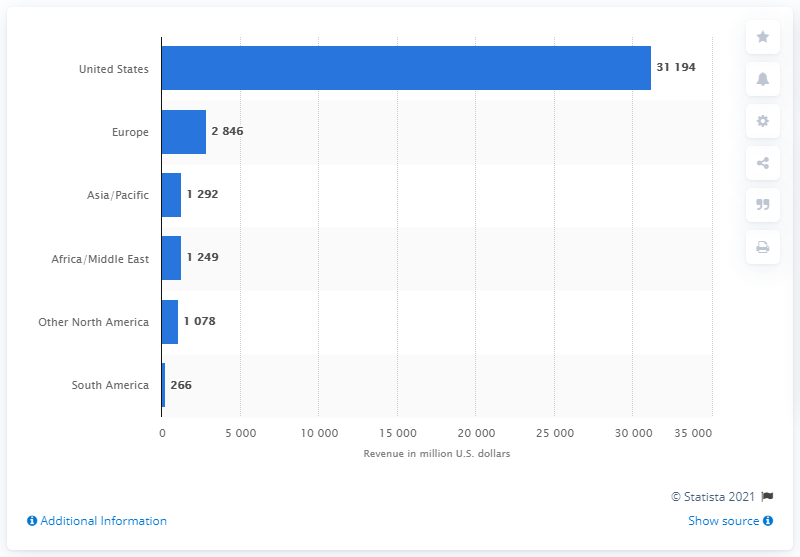Highlight a few significant elements in this photo. General Dynamics generated $28.46 billion in revenue in Europe in 2020. 